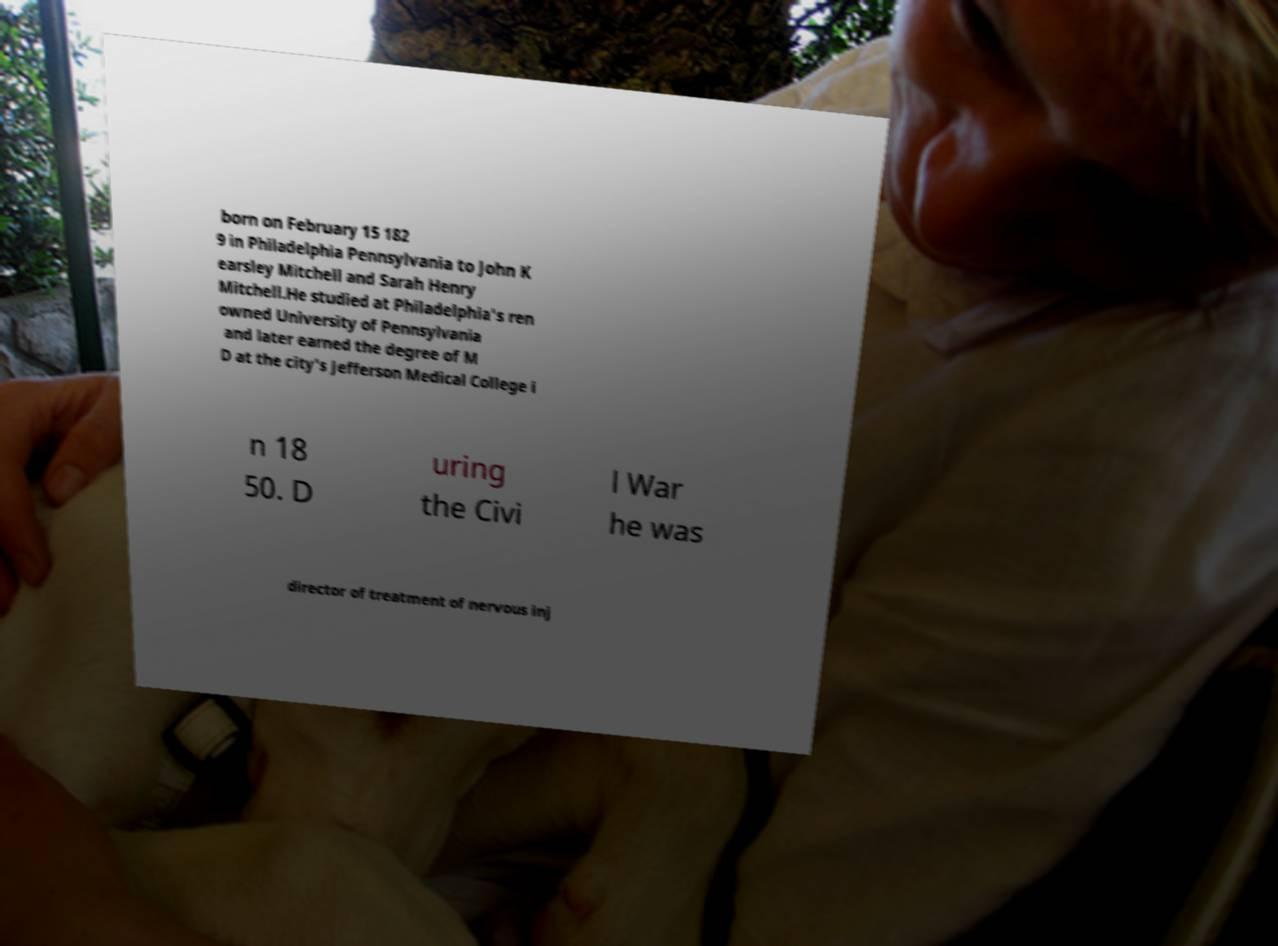Could you assist in decoding the text presented in this image and type it out clearly? born on February 15 182 9 in Philadelphia Pennsylvania to John K earsley Mitchell and Sarah Henry Mitchell.He studied at Philadelphia's ren owned University of Pennsylvania and later earned the degree of M D at the city's Jefferson Medical College i n 18 50. D uring the Civi l War he was director of treatment of nervous inj 